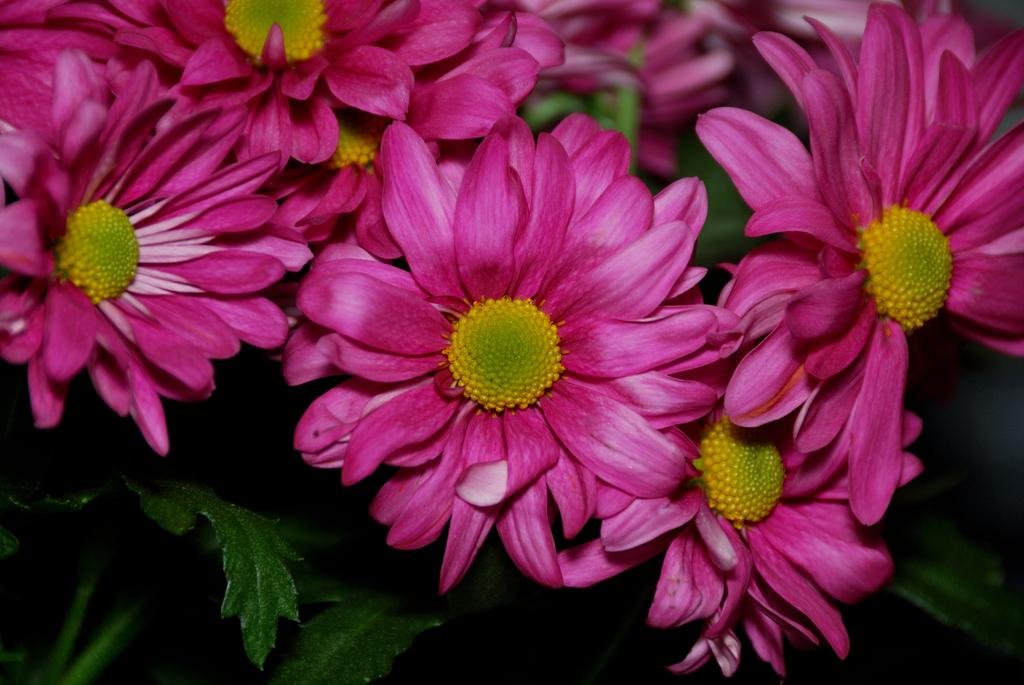What type of plants can be seen in the image? There are flowers in the image. What else can be seen in the background of the image? There are leaves in the background of the image. How much money is being exchanged between the yaks in the image? There are no yaks present in the image, and therefore no exchange of money can be observed. 